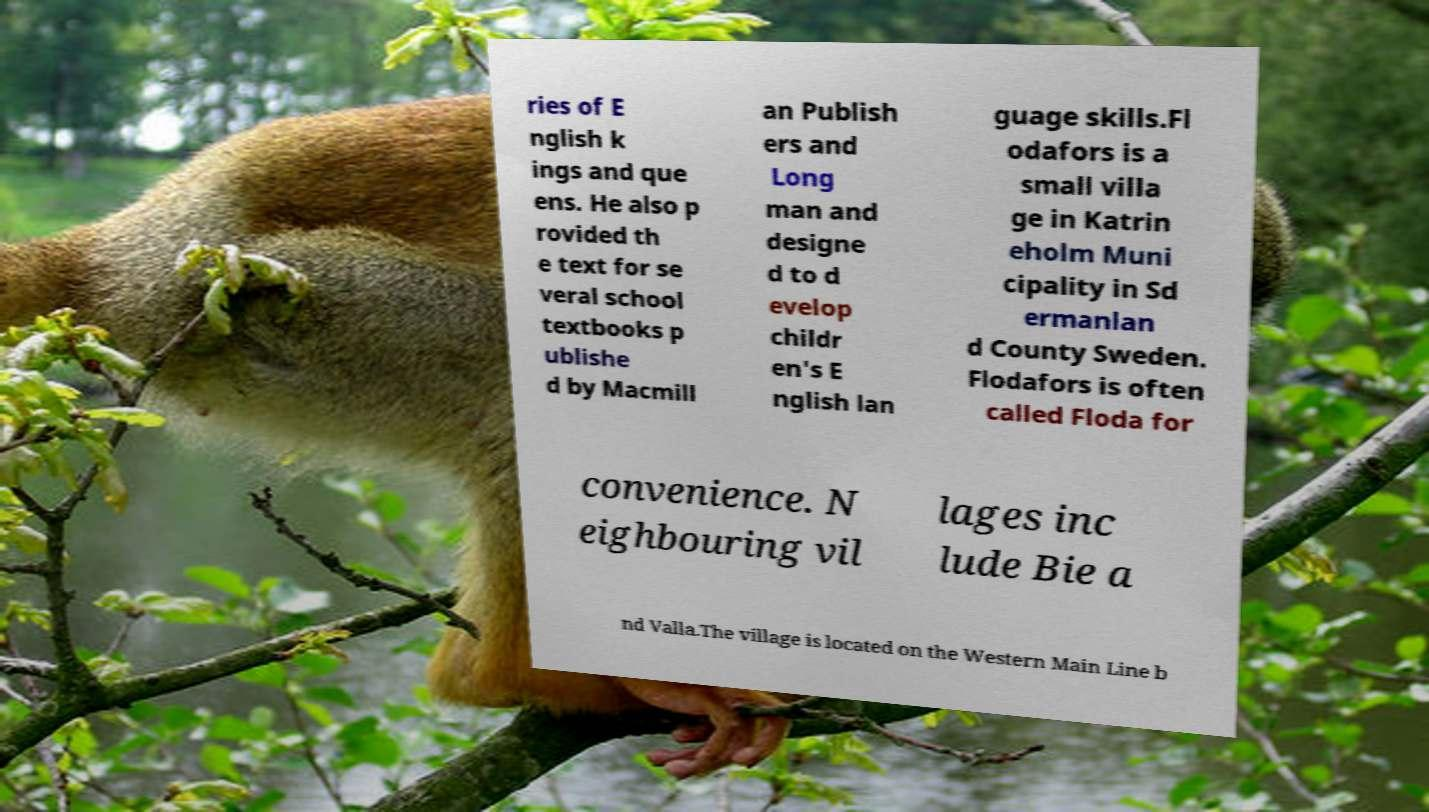What messages or text are displayed in this image? I need them in a readable, typed format. ries of E nglish k ings and que ens. He also p rovided th e text for se veral school textbooks p ublishe d by Macmill an Publish ers and Long man and designe d to d evelop childr en's E nglish lan guage skills.Fl odafors is a small villa ge in Katrin eholm Muni cipality in Sd ermanlan d County Sweden. Flodafors is often called Floda for convenience. N eighbouring vil lages inc lude Bie a nd Valla.The village is located on the Western Main Line b 